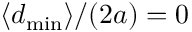<formula> <loc_0><loc_0><loc_500><loc_500>\langle d _ { \min } \rangle / ( 2 a ) = 0</formula> 